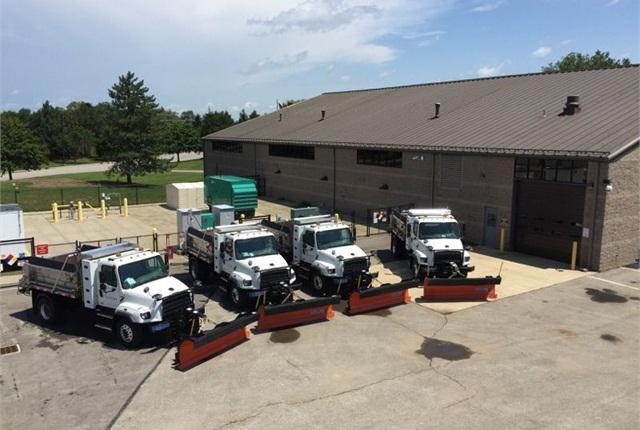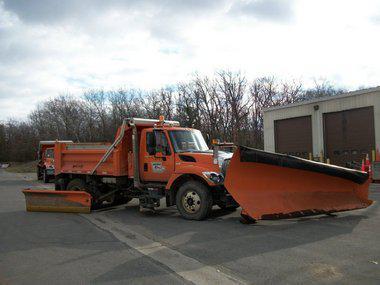The first image is the image on the left, the second image is the image on the right. Analyze the images presented: Is the assertion "There is at least one blue truck in the images." valid? Answer yes or no. No. 